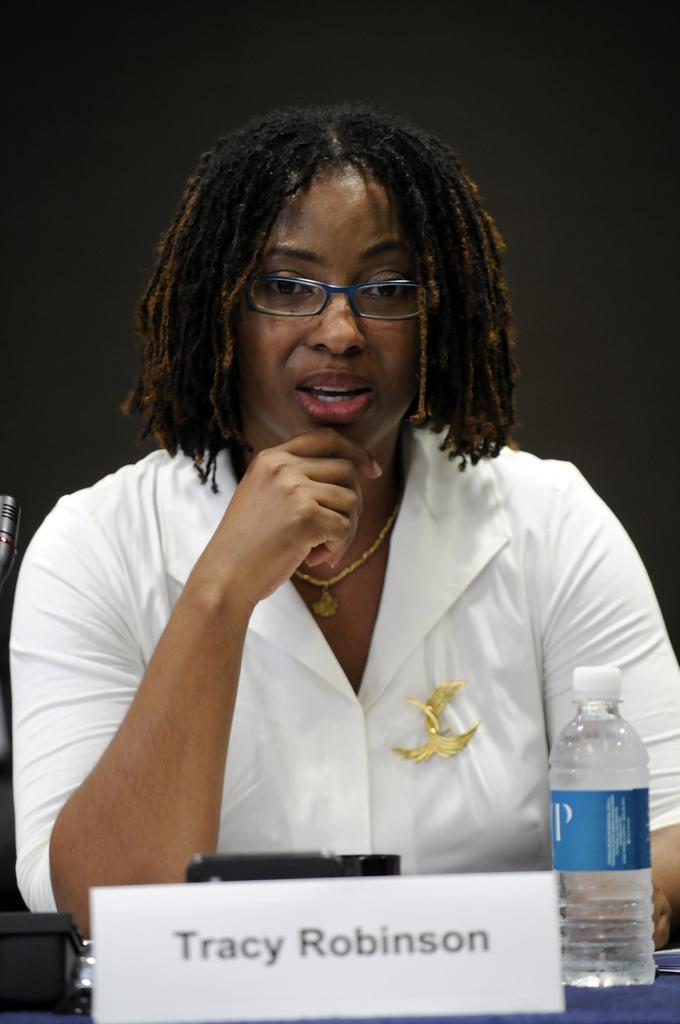Can you describe this image briefly? In the image we can see women wearing spectacle and white color shirt. There is a water bottle in front of her and a name plate. 